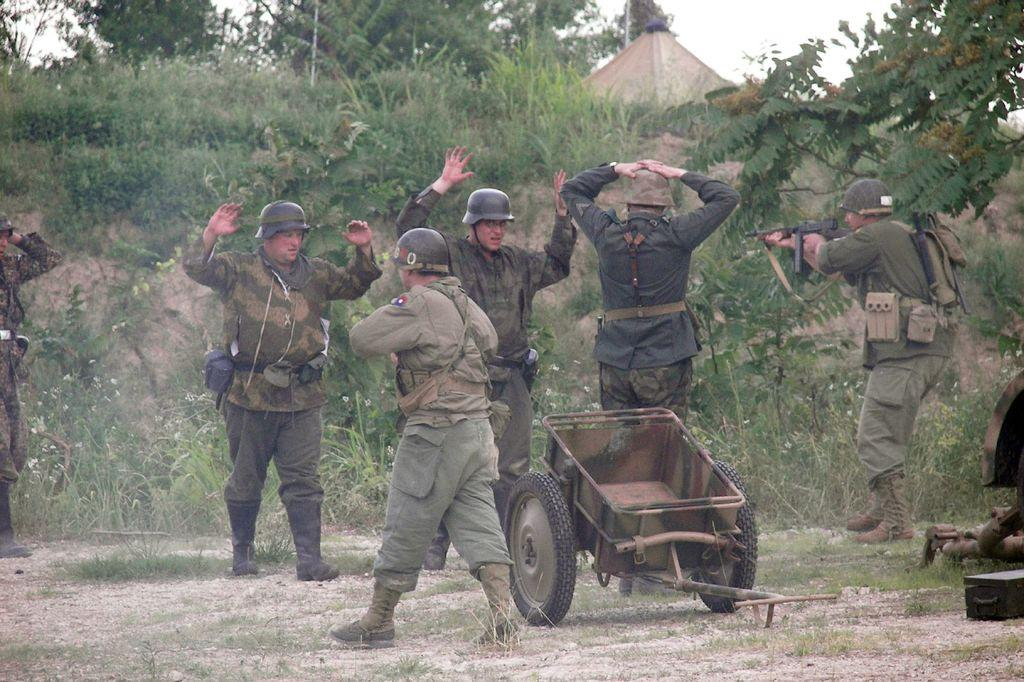What type of headgear are the people wearing in the image? The people are wearing helmets in the image. What type of clothing are the people wearing? The people are wearing army dress in the image. What is the purpose of the cart in the image? The purpose of the cart in the image is not specified, but it is likely being used to transport items or people. What type of vegetation is present in the image? There are plants, trees, and grass in the image. What part of the natural environment is visible in the image? The sky is visible in the image. What type of pan is being used to cook food in the image? There is no pan or cooking activity present in the image. How does the image compare to a similar image of people wearing helmets and army dress in a different setting? The image cannot be compared to another image, as only one image is being described. 